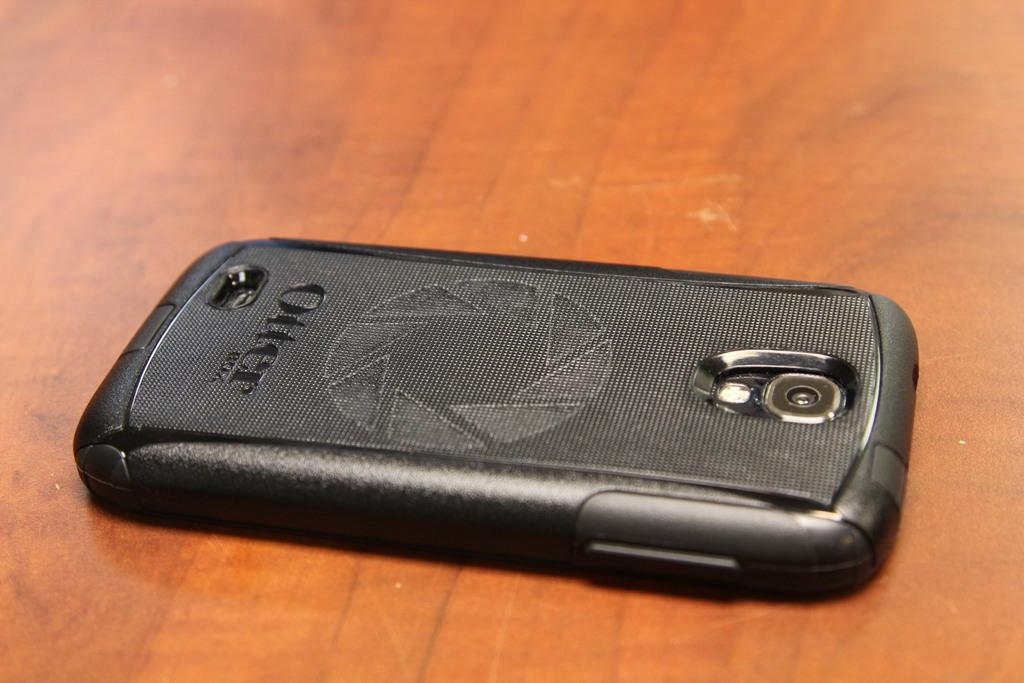<image>
Summarize the visual content of the image. A black Otter cell phone lays face down on a wood surface. 